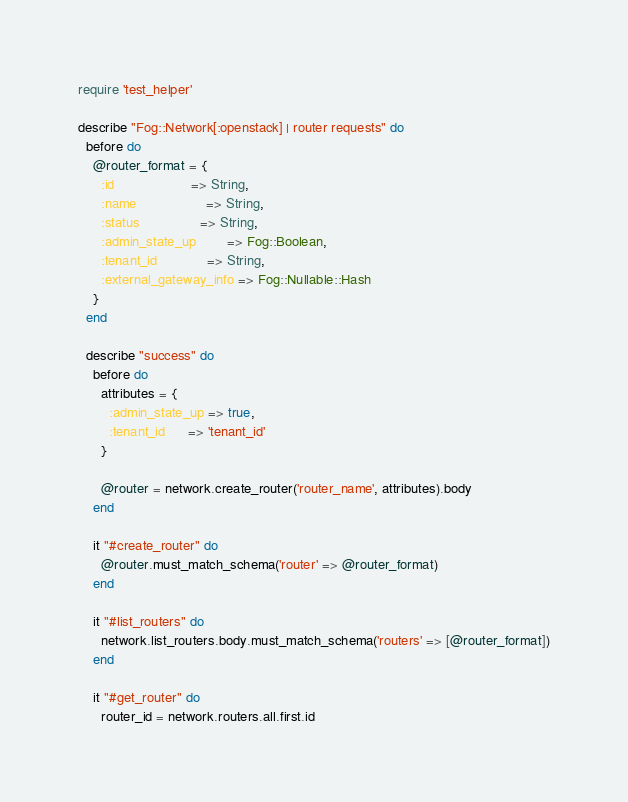Convert code to text. <code><loc_0><loc_0><loc_500><loc_500><_Ruby_>require 'test_helper'

describe "Fog::Network[:openstack] | router requests" do
  before do
    @router_format = {
      :id                    => String,
      :name                  => String,
      :status                => String,
      :admin_state_up        => Fog::Boolean,
      :tenant_id             => String,
      :external_gateway_info => Fog::Nullable::Hash
    }
  end

  describe "success" do
    before do
      attributes = {
        :admin_state_up => true,
        :tenant_id      => 'tenant_id'
      }

      @router = network.create_router('router_name', attributes).body
    end

    it "#create_router" do
      @router.must_match_schema('router' => @router_format)
    end

    it "#list_routers" do
      network.list_routers.body.must_match_schema('routers' => [@router_format])
    end

    it "#get_router" do
      router_id = network.routers.all.first.id</code> 